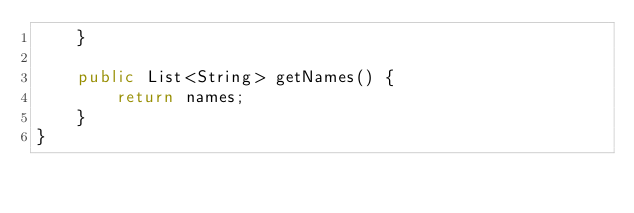<code> <loc_0><loc_0><loc_500><loc_500><_Java_>    }

    public List<String> getNames() {
        return names;
    }
}
</code> 